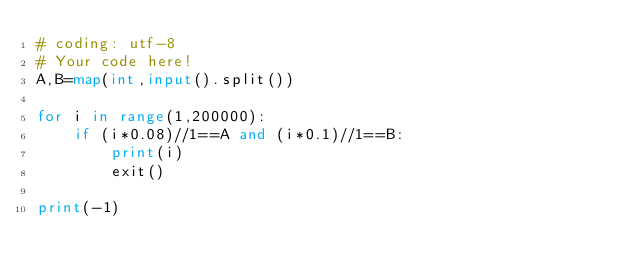Convert code to text. <code><loc_0><loc_0><loc_500><loc_500><_Python_># coding: utf-8
# Your code here!
A,B=map(int,input().split())

for i in range(1,200000):
    if (i*0.08)//1==A and (i*0.1)//1==B:
        print(i)
        exit()

print(-1)</code> 